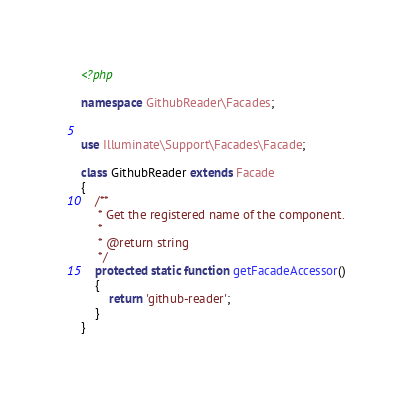<code> <loc_0><loc_0><loc_500><loc_500><_PHP_><?php

namespace GithubReader\Facades;


use Illuminate\Support\Facades\Facade;

class GithubReader extends Facade
{
    /**
     * Get the registered name of the component.
     *
     * @return string
     */
    protected static function getFacadeAccessor()
    {
        return 'github-reader';
    }
}</code> 